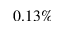<formula> <loc_0><loc_0><loc_500><loc_500>0 . 1 3 \%</formula> 